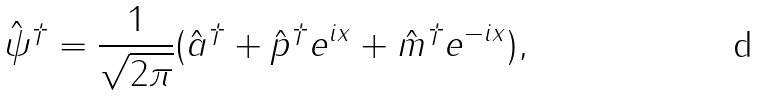<formula> <loc_0><loc_0><loc_500><loc_500>\hat { \psi } ^ { \dagger } = \frac { 1 } { \sqrt { 2 \pi } } ( \hat { a } ^ { \dagger } + \hat { p } ^ { \dagger } e ^ { i x } + \hat { m } ^ { \dagger } e ^ { - i x } ) ,</formula> 